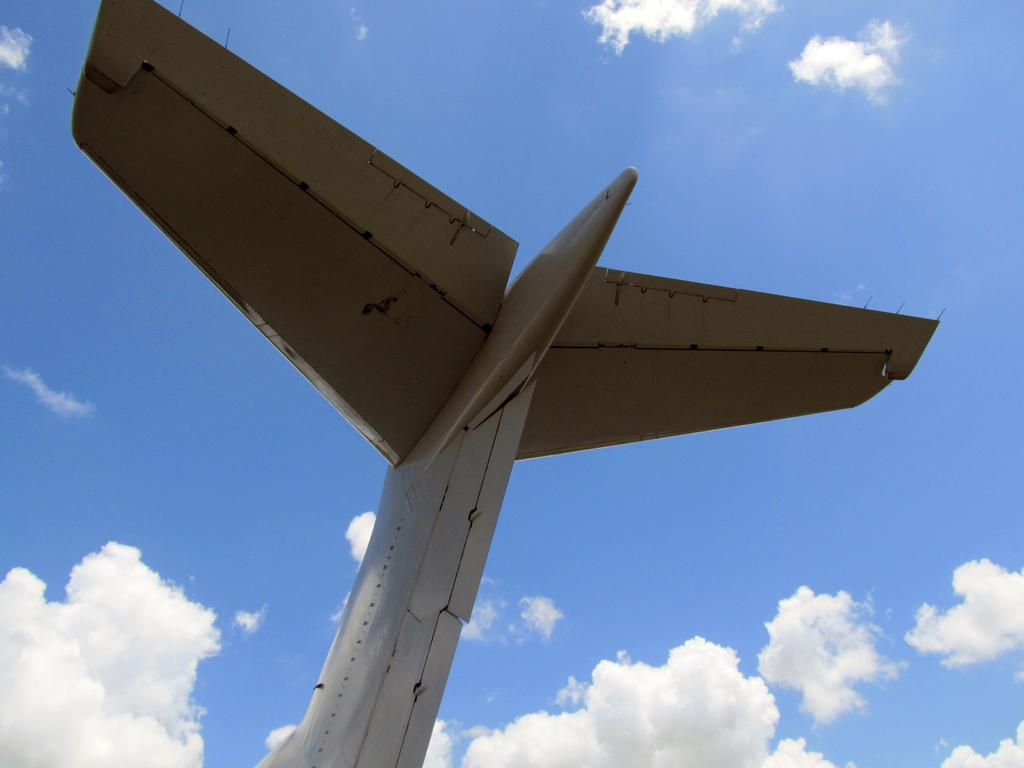What is the main subject of the image? The main subject of the image is the wings of an aircraft. What can be seen in the background of the image? The image shows a sky with clouds in the background. What type of pocket can be seen in the image? There is no pocket present in the image; it features the wings of an aircraft and a sky with clouds. What is the company that manufactures the aircraft in the image? The image does not provide enough information to determine the manufacturer of the aircraft. 